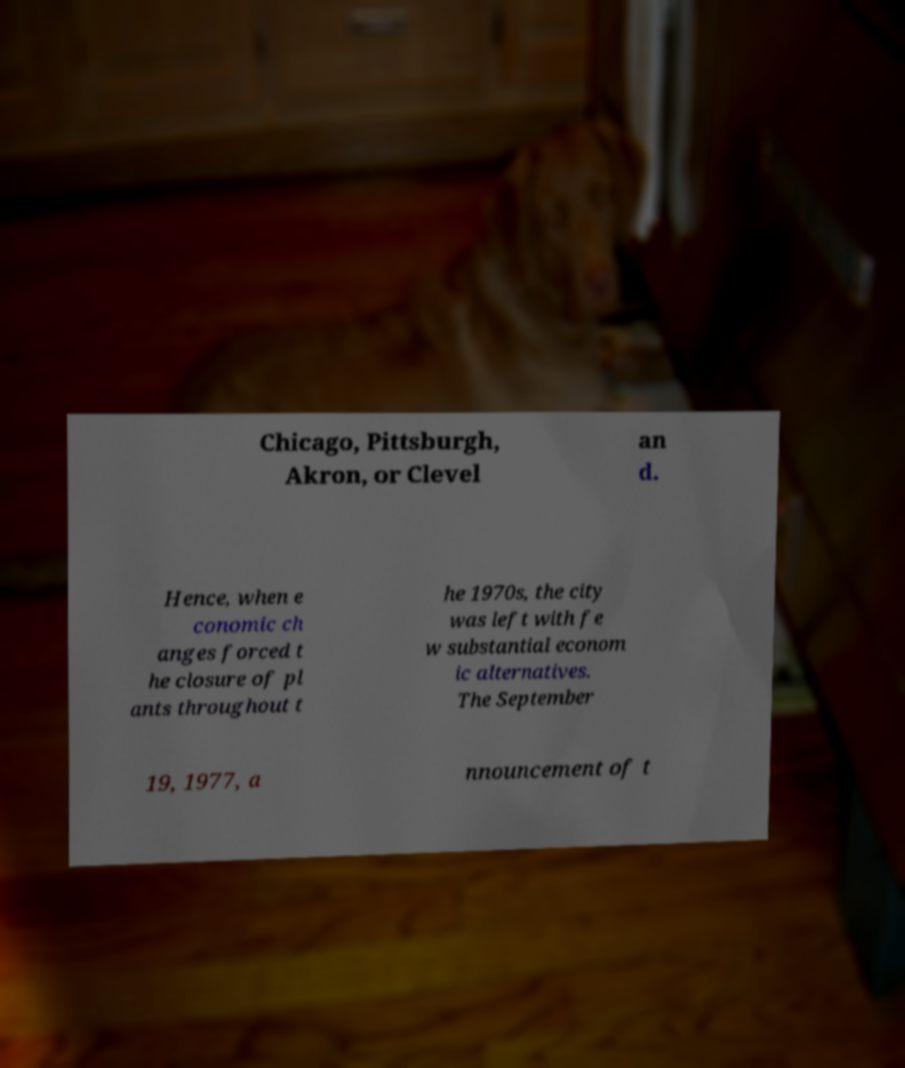What messages or text are displayed in this image? I need them in a readable, typed format. Chicago, Pittsburgh, Akron, or Clevel an d. Hence, when e conomic ch anges forced t he closure of pl ants throughout t he 1970s, the city was left with fe w substantial econom ic alternatives. The September 19, 1977, a nnouncement of t 